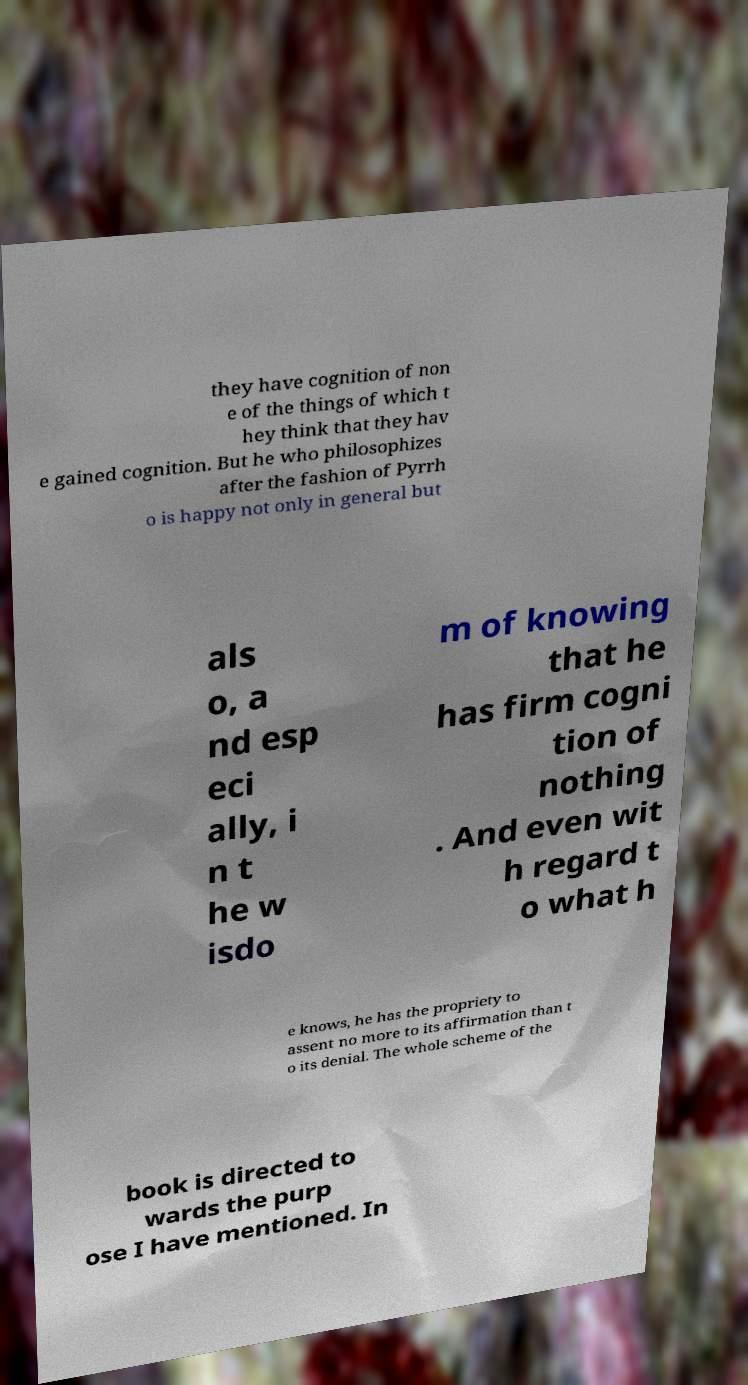There's text embedded in this image that I need extracted. Can you transcribe it verbatim? they have cognition of non e of the things of which t hey think that they hav e gained cognition. But he who philosophizes after the fashion of Pyrrh o is happy not only in general but als o, a nd esp eci ally, i n t he w isdo m of knowing that he has firm cogni tion of nothing . And even wit h regard t o what h e knows, he has the propriety to assent no more to its affirmation than t o its denial. The whole scheme of the book is directed to wards the purp ose I have mentioned. In 